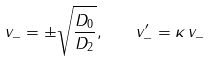<formula> <loc_0><loc_0><loc_500><loc_500>v _ { - } = \pm \sqrt { \frac { D _ { 0 } } { D _ { 2 } } } , \quad v ^ { \prime } _ { - } = \kappa \, v _ { - }</formula> 